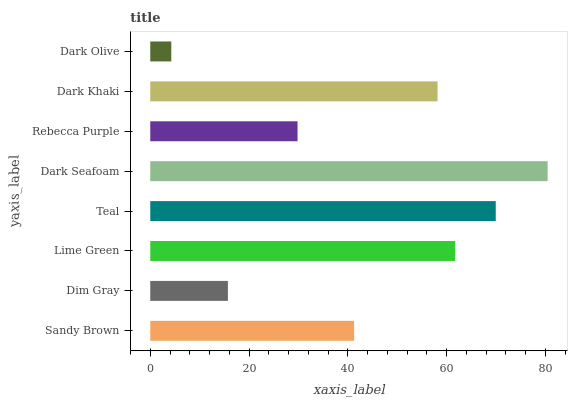Is Dark Olive the minimum?
Answer yes or no. Yes. Is Dark Seafoam the maximum?
Answer yes or no. Yes. Is Dim Gray the minimum?
Answer yes or no. No. Is Dim Gray the maximum?
Answer yes or no. No. Is Sandy Brown greater than Dim Gray?
Answer yes or no. Yes. Is Dim Gray less than Sandy Brown?
Answer yes or no. Yes. Is Dim Gray greater than Sandy Brown?
Answer yes or no. No. Is Sandy Brown less than Dim Gray?
Answer yes or no. No. Is Dark Khaki the high median?
Answer yes or no. Yes. Is Sandy Brown the low median?
Answer yes or no. Yes. Is Lime Green the high median?
Answer yes or no. No. Is Teal the low median?
Answer yes or no. No. 